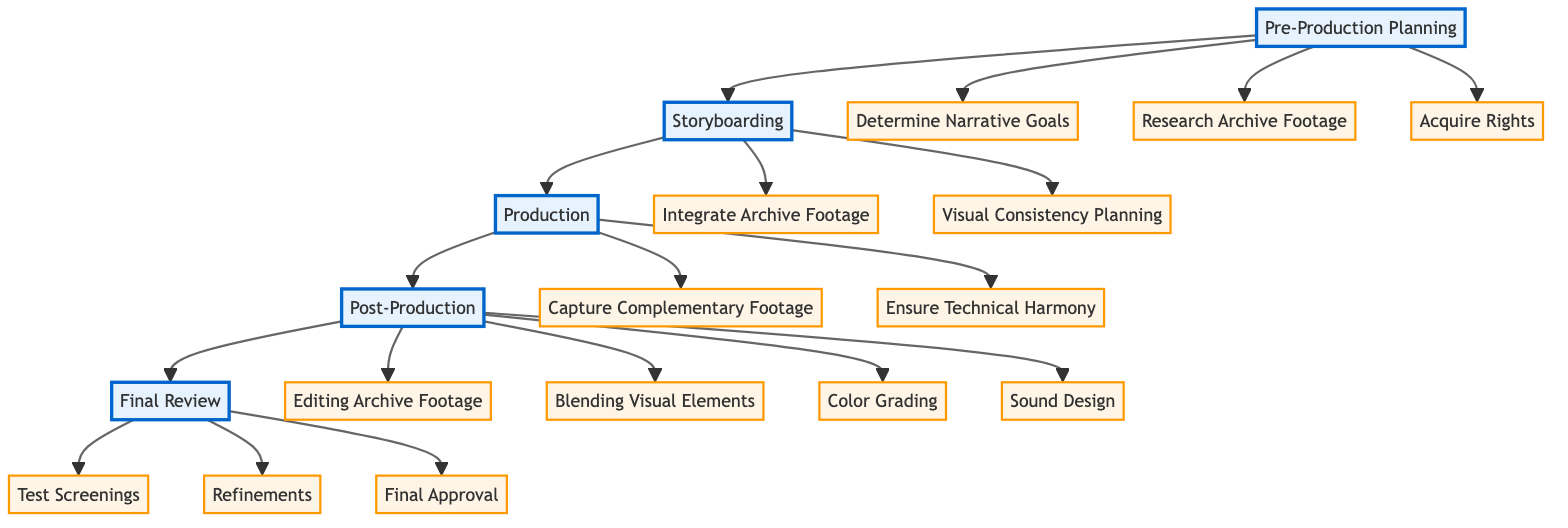What is the first step in the Pre-Production Planning phase? The diagram specifies that the first step in the Pre-Production Planning phase is "Determine Narrative Goals." This can be found directly connected to the "Pre-Production Planning" node.
Answer: Determine Narrative Goals How many steps are in the Post-Production phase? By counting the steps connected to the "Post-Production" node, we see there are four steps: "Editing Archive Footage," "Blending Visual Elements," "Color Grading," and "Sound Design."
Answer: 4 What phase comes before Production? The phases are sequentially connected in the diagram. "Storyboarding" is the phase immediately before "Production."
Answer: Storyboarding What is the last step in the Final Review phase? The final step is indicated as "Final Approval" which is the last node connected to "Final Review."
Answer: Final Approval Which step is focused on visual consistency? The diagram shows that "Visual Consistency Planning" is the step that concentrates on maintaining consistency between archive and new footage, directly connected under the Storyboarding phase.
Answer: Visual Consistency Planning What two steps are essential for ensuring a smooth audio-visual integration? To ensure a seamless integration, "Sound Design" relates to audio, while "Blending Visual Elements" pertains to visual aspects, both residing in the Post-Production phase. Thus, these two steps are critical for this quality.
Answer: Sound Design and Blending Visual Elements What is required before acquiring rights in the Pre-Production phase? The step "Research Archive Footage" is necessary to be conducted before "Acquire Rights," establishing a dependency where archival footage is evaluated before rights are secured.
Answer: Research Archive Footage Which step in Production helps match technical qualities of footage? The step for matching technical qualities is "Ensure Technical Harmony," which is connected to the Production phase explicitly focusing on camera techniques and settings.
Answer: Ensure Technical Harmony What is the relationship between Storyboarding and Post-Production phases? The relationship is sequential; "Storyboarding" comes before the "Post-Production" phase indicating planning precedes the actual editing and production processes.
Answer: Sequential relationship 